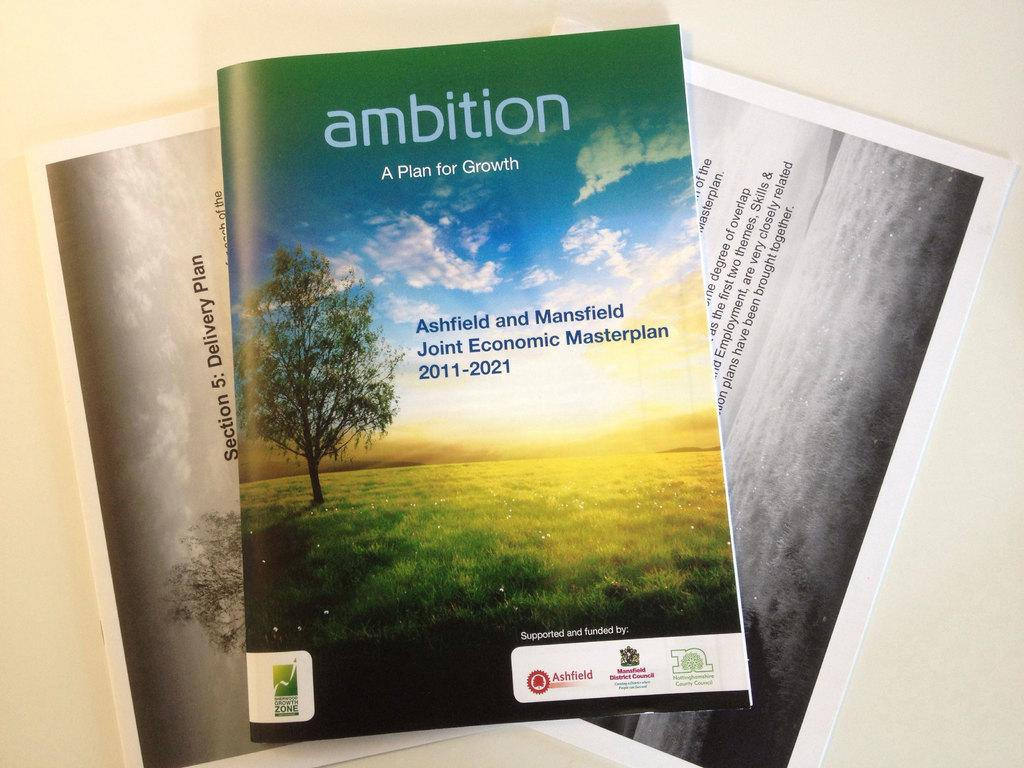What is present in the image that can be used for reading or learning? There is a book in the image that can be used for reading or learning. What else can be seen in the image that is related to reading or learning? There are papers in the image that can also be used for reading or learning. Where are the book and papers located in the image? The book and papers are placed on a surface in the image. What can be found on the book and papers in the image? The book and papers contain pictures and text in the image. What type of crowd can be seen gathering around the book and papers in the image? There is no crowd present in the image; it only shows the book and papers placed on a surface. 